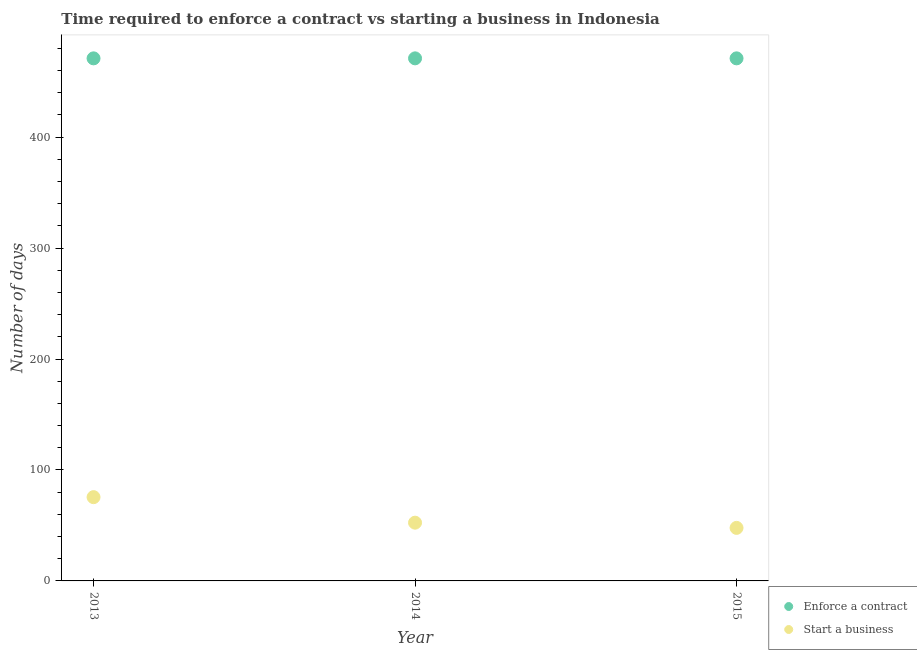How many different coloured dotlines are there?
Provide a short and direct response. 2. Is the number of dotlines equal to the number of legend labels?
Keep it short and to the point. Yes. What is the number of days to enforece a contract in 2014?
Provide a short and direct response. 471. Across all years, what is the maximum number of days to enforece a contract?
Provide a succinct answer. 471. Across all years, what is the minimum number of days to start a business?
Your answer should be very brief. 47.8. In which year was the number of days to start a business maximum?
Your answer should be compact. 2013. In which year was the number of days to start a business minimum?
Your answer should be compact. 2015. What is the total number of days to enforece a contract in the graph?
Your answer should be compact. 1413. What is the difference between the number of days to enforece a contract in 2014 and that in 2015?
Keep it short and to the point. 0. What is the difference between the number of days to enforece a contract in 2014 and the number of days to start a business in 2013?
Give a very brief answer. 395.5. What is the average number of days to start a business per year?
Offer a terse response. 58.6. In the year 2015, what is the difference between the number of days to enforece a contract and number of days to start a business?
Your response must be concise. 423.2. In how many years, is the number of days to start a business greater than 220 days?
Give a very brief answer. 0. What is the ratio of the number of days to enforece a contract in 2014 to that in 2015?
Offer a very short reply. 1. Is the number of days to start a business in 2014 less than that in 2015?
Provide a succinct answer. No. Is the difference between the number of days to start a business in 2014 and 2015 greater than the difference between the number of days to enforece a contract in 2014 and 2015?
Your answer should be compact. Yes. What is the difference between the highest and the second highest number of days to start a business?
Your answer should be compact. 23. What is the difference between the highest and the lowest number of days to enforece a contract?
Give a very brief answer. 0. Does the number of days to start a business monotonically increase over the years?
Make the answer very short. No. Is the number of days to start a business strictly less than the number of days to enforece a contract over the years?
Give a very brief answer. Yes. What is the difference between two consecutive major ticks on the Y-axis?
Offer a very short reply. 100. Where does the legend appear in the graph?
Offer a very short reply. Bottom right. What is the title of the graph?
Offer a terse response. Time required to enforce a contract vs starting a business in Indonesia. Does "Nitrous oxide emissions" appear as one of the legend labels in the graph?
Keep it short and to the point. No. What is the label or title of the Y-axis?
Offer a very short reply. Number of days. What is the Number of days of Enforce a contract in 2013?
Your answer should be very brief. 471. What is the Number of days in Start a business in 2013?
Keep it short and to the point. 75.5. What is the Number of days in Enforce a contract in 2014?
Your answer should be compact. 471. What is the Number of days in Start a business in 2014?
Your response must be concise. 52.5. What is the Number of days in Enforce a contract in 2015?
Your answer should be very brief. 471. What is the Number of days of Start a business in 2015?
Make the answer very short. 47.8. Across all years, what is the maximum Number of days of Enforce a contract?
Ensure brevity in your answer.  471. Across all years, what is the maximum Number of days of Start a business?
Keep it short and to the point. 75.5. Across all years, what is the minimum Number of days of Enforce a contract?
Ensure brevity in your answer.  471. Across all years, what is the minimum Number of days of Start a business?
Offer a terse response. 47.8. What is the total Number of days of Enforce a contract in the graph?
Your answer should be very brief. 1413. What is the total Number of days in Start a business in the graph?
Offer a terse response. 175.8. What is the difference between the Number of days of Enforce a contract in 2013 and that in 2014?
Your answer should be compact. 0. What is the difference between the Number of days of Start a business in 2013 and that in 2014?
Provide a short and direct response. 23. What is the difference between the Number of days of Enforce a contract in 2013 and that in 2015?
Offer a terse response. 0. What is the difference between the Number of days in Start a business in 2013 and that in 2015?
Your answer should be compact. 27.7. What is the difference between the Number of days in Enforce a contract in 2014 and that in 2015?
Give a very brief answer. 0. What is the difference between the Number of days in Enforce a contract in 2013 and the Number of days in Start a business in 2014?
Your response must be concise. 418.5. What is the difference between the Number of days of Enforce a contract in 2013 and the Number of days of Start a business in 2015?
Make the answer very short. 423.2. What is the difference between the Number of days of Enforce a contract in 2014 and the Number of days of Start a business in 2015?
Keep it short and to the point. 423.2. What is the average Number of days in Enforce a contract per year?
Offer a terse response. 471. What is the average Number of days in Start a business per year?
Offer a terse response. 58.6. In the year 2013, what is the difference between the Number of days in Enforce a contract and Number of days in Start a business?
Make the answer very short. 395.5. In the year 2014, what is the difference between the Number of days of Enforce a contract and Number of days of Start a business?
Your answer should be very brief. 418.5. In the year 2015, what is the difference between the Number of days of Enforce a contract and Number of days of Start a business?
Provide a succinct answer. 423.2. What is the ratio of the Number of days of Enforce a contract in 2013 to that in 2014?
Offer a terse response. 1. What is the ratio of the Number of days of Start a business in 2013 to that in 2014?
Give a very brief answer. 1.44. What is the ratio of the Number of days in Enforce a contract in 2013 to that in 2015?
Provide a succinct answer. 1. What is the ratio of the Number of days in Start a business in 2013 to that in 2015?
Provide a short and direct response. 1.58. What is the ratio of the Number of days in Start a business in 2014 to that in 2015?
Your answer should be compact. 1.1. What is the difference between the highest and the second highest Number of days of Enforce a contract?
Make the answer very short. 0. What is the difference between the highest and the lowest Number of days in Enforce a contract?
Make the answer very short. 0. What is the difference between the highest and the lowest Number of days in Start a business?
Offer a very short reply. 27.7. 